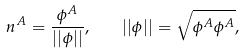<formula> <loc_0><loc_0><loc_500><loc_500>n ^ { A } = \frac { \phi ^ { A } } { | | \phi | | } , \quad | | \phi | | = \sqrt { \phi ^ { A } \phi ^ { A } } ,</formula> 